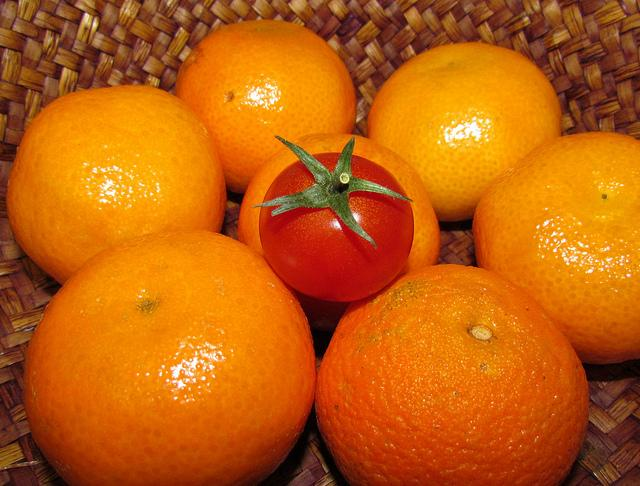What vegetable is shown in the picture?

Choices:
A) broccoli
B) lettuce
C) tomato
D) spinach tomato 